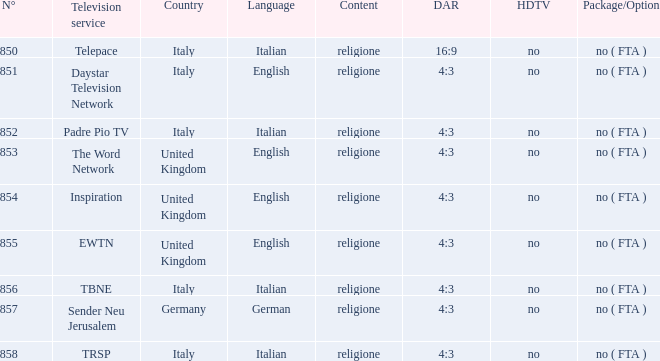How many television service are in italian and n°is greater than 856.0? TRSP. 